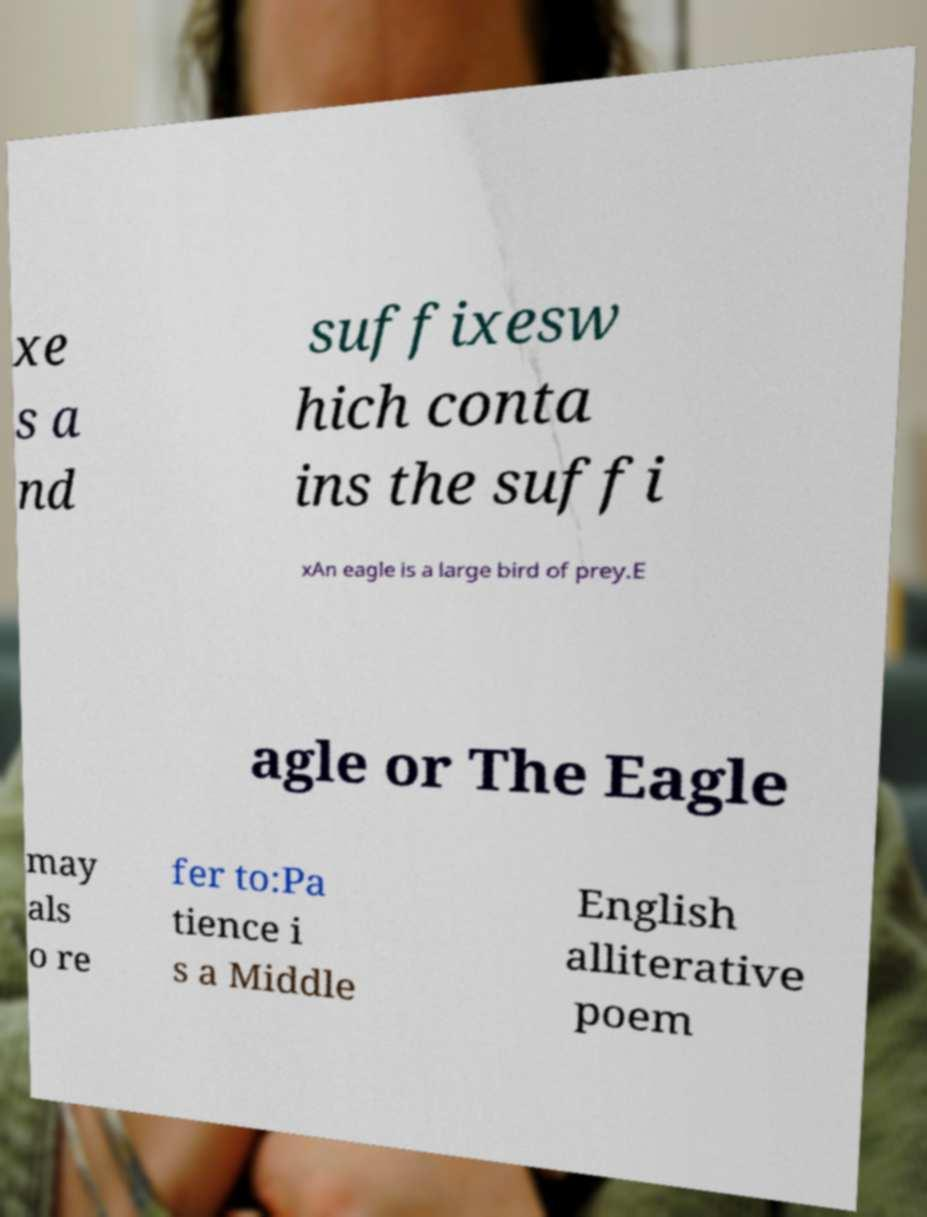Please identify and transcribe the text found in this image. xe s a nd suffixesw hich conta ins the suffi xAn eagle is a large bird of prey.E agle or The Eagle may als o re fer to:Pa tience i s a Middle English alliterative poem 